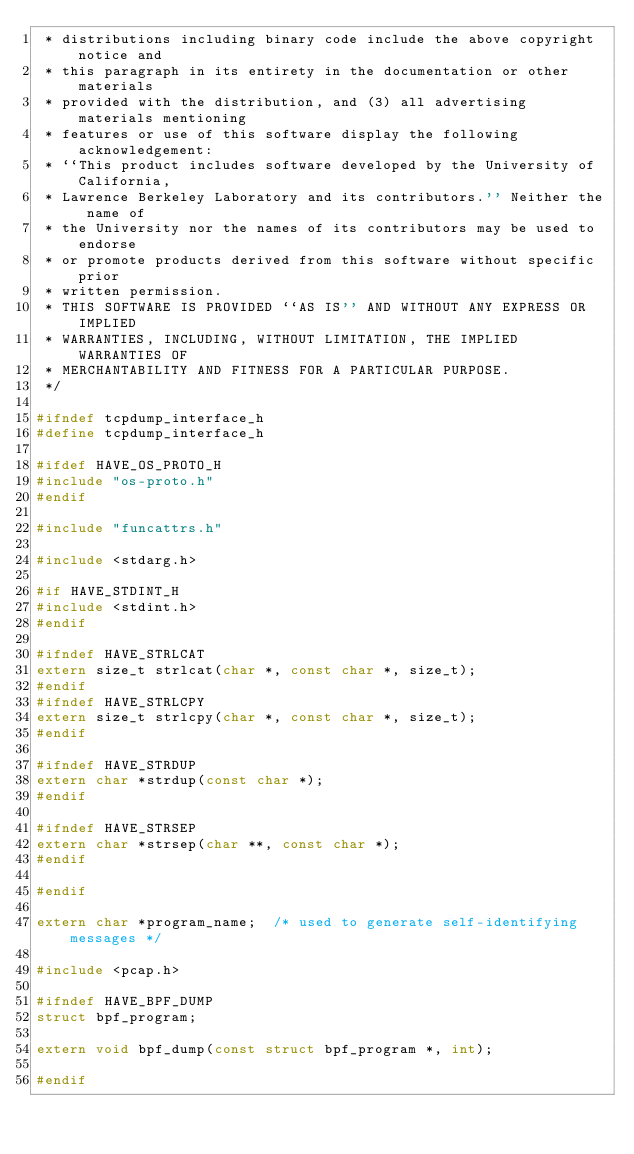Convert code to text. <code><loc_0><loc_0><loc_500><loc_500><_C_> * distributions including binary code include the above copyright notice and
 * this paragraph in its entirety in the documentation or other materials
 * provided with the distribution, and (3) all advertising materials mentioning
 * features or use of this software display the following acknowledgement:
 * ``This product includes software developed by the University of California,
 * Lawrence Berkeley Laboratory and its contributors.'' Neither the name of
 * the University nor the names of its contributors may be used to endorse
 * or promote products derived from this software without specific prior
 * written permission.
 * THIS SOFTWARE IS PROVIDED ``AS IS'' AND WITHOUT ANY EXPRESS OR IMPLIED
 * WARRANTIES, INCLUDING, WITHOUT LIMITATION, THE IMPLIED WARRANTIES OF
 * MERCHANTABILITY AND FITNESS FOR A PARTICULAR PURPOSE.
 */

#ifndef tcpdump_interface_h
#define tcpdump_interface_h

#ifdef HAVE_OS_PROTO_H
#include "os-proto.h"
#endif

#include "funcattrs.h"

#include <stdarg.h>

#if HAVE_STDINT_H
#include <stdint.h>
#endif

#ifndef HAVE_STRLCAT
extern size_t strlcat(char *, const char *, size_t);
#endif
#ifndef HAVE_STRLCPY
extern size_t strlcpy(char *, const char *, size_t);
#endif

#ifndef HAVE_STRDUP
extern char *strdup(const char *);
#endif

#ifndef HAVE_STRSEP
extern char *strsep(char **, const char *);
#endif

#endif

extern char *program_name;	/* used to generate self-identifying messages */

#include <pcap.h>

#ifndef HAVE_BPF_DUMP
struct bpf_program;

extern void bpf_dump(const struct bpf_program *, int);

#endif
</code> 